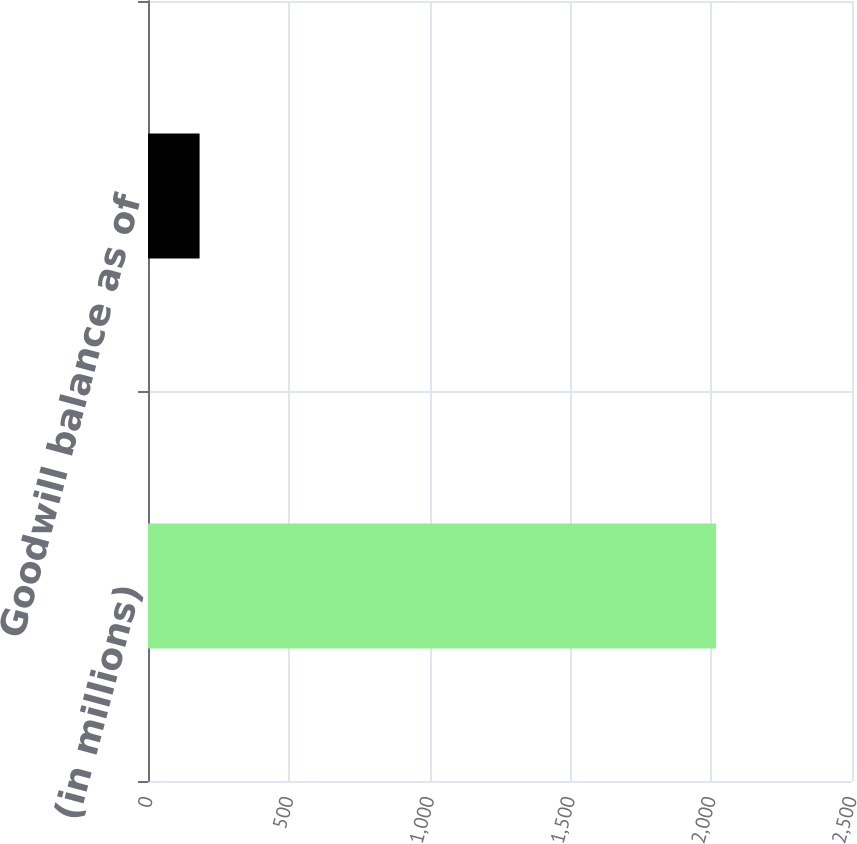Convert chart to OTSL. <chart><loc_0><loc_0><loc_500><loc_500><bar_chart><fcel>(in millions)<fcel>Goodwill balance as of<nl><fcel>2017<fcel>183.2<nl></chart> 